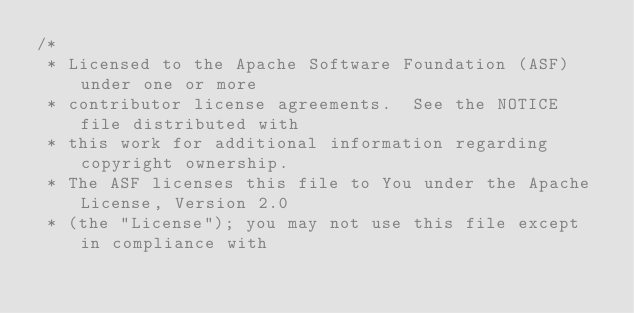Convert code to text. <code><loc_0><loc_0><loc_500><loc_500><_Java_>/*
 * Licensed to the Apache Software Foundation (ASF) under one or more
 * contributor license agreements.  See the NOTICE file distributed with
 * this work for additional information regarding copyright ownership.
 * The ASF licenses this file to You under the Apache License, Version 2.0
 * (the "License"); you may not use this file except in compliance with</code> 